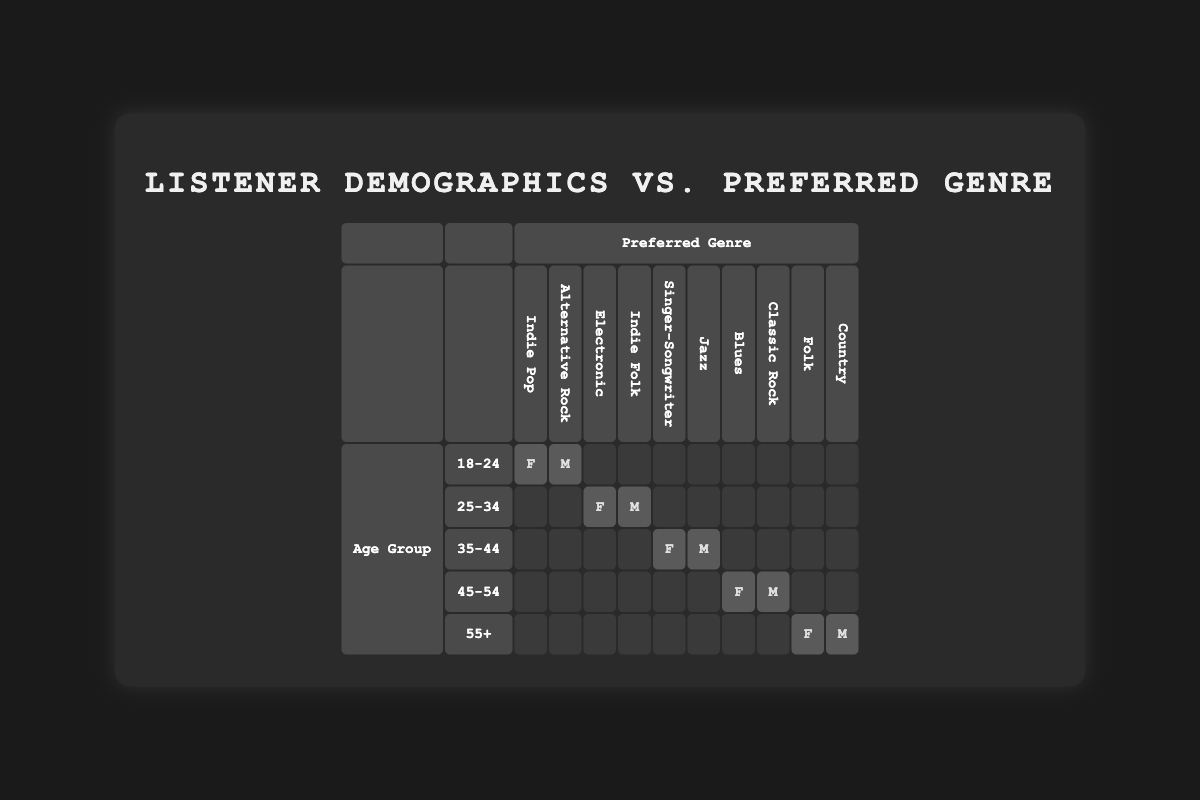What are the preferred genres of listeners aged 18-24? In the table, we look at the row for age group 18-24. The preferred genres listed are Indie Pop for females and Alternative Rock for males.
Answer: Indie Pop, Alternative Rock How many females prefer Electronic music? The table indicates that the preferred genre Electronic is associated with females in the age group 25-34. Therefore, there is 1 female who prefers Electronic music.
Answer: 1 Which preferred genre is associated with the oldest age group of listeners? By checking the 55+ row, we find that the preferred genres are Folk for females and Country for males. Therefore, both genres are associated with this group.
Answer: Folk, Country Is Indie Folk the only preferred genre for males aged 25-34? In the table, males aged 25-34 also have Indie Folk as their preferred genre along with  Electronic as a preferred genre for females in the same age group. Therefore, Indie Folk is not the only genre.
Answer: No Which age group has the highest number of preferred genres listed? Looking at the table, every row represents one preferred genre per gender for each age group. The 18-24 age group has 2 genres, and all other groups also have only 2 genres, indicating there is no age group with a higher number listed.
Answer: All age groups have the same number How many males prefer Blues and Jazz combined? In the table, Blues is listed under 45-54 for females, while Jazz is listed under 35-44 for males. Therefore, the count for males who prefer Blues is 0, and the count for males who prefer Jazz is 1. Adding these gives us 1.
Answer: 1 What is the difference in preferred genres between the 35-44 and 45-54 age groups? The 35-44 row shows Singer-Songwriter for females and Jazz for males, while the 45-54 row shows Blues for females and Classic Rock for males. Therefore, there are 2 genres for 35-44 and 2 genres for 45-54. The difference in number is therefore 0.
Answer: 0 Are there any age groups that have the same preferred genre for both genders? No row shows the same genre for both males and females; thus, there are no age groups with identical preferred genres for both genders.
Answer: No What is the total number of preferred genres in the table? The table indicates a total of 10 preferred genres. Each row represents one genre for each gender, with 5 age groups; thus, adding across gives us a total of 10 genres.
Answer: 10 